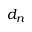<formula> <loc_0><loc_0><loc_500><loc_500>d _ { n }</formula> 